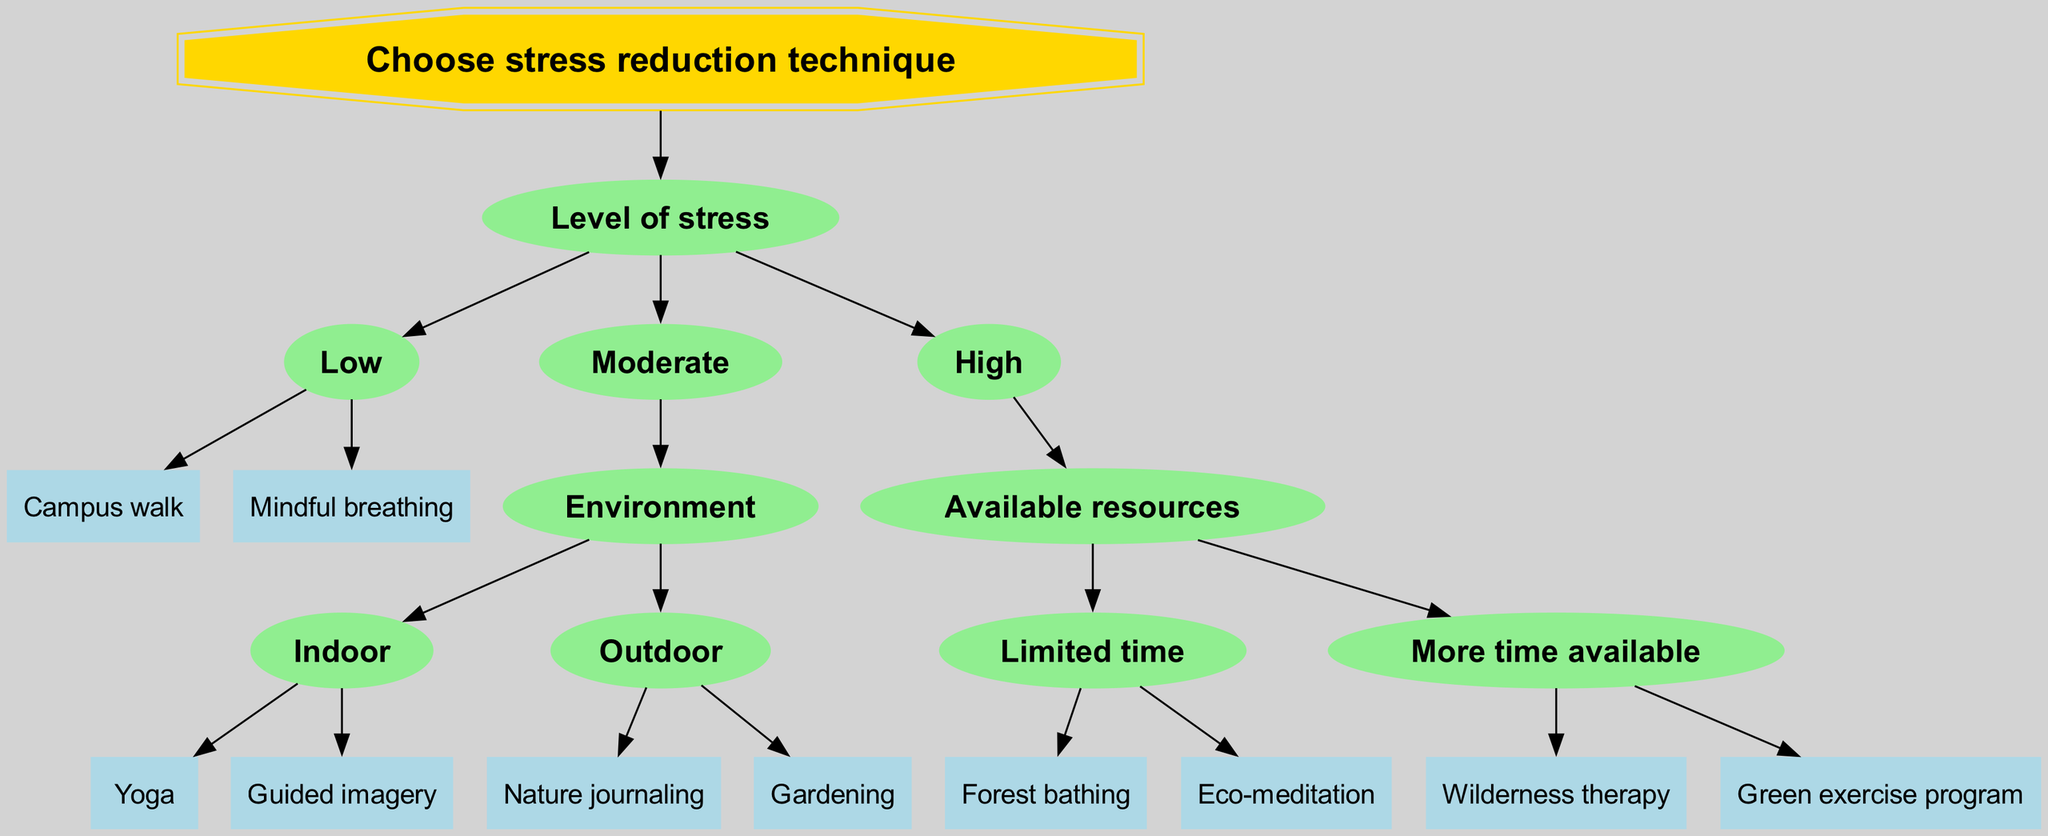What is the root node of the decision tree? The root node of the decision tree is the starting point from which all other nodes branch out. In this case, it is labeled "Choose stress reduction technique."
Answer: Choose stress reduction technique How many techniques are available for low stress levels? There are two techniques indicated under the "Low" stress level node, which are "Campus walk" and "Mindful breathing."
Answer: 2 Which technique is recommended for high stress with limited time? In the "High" stress level branch under "Limited time," there are two techniques specified, and one of them is "Forest bathing."
Answer: Forest bathing What are the options available for moderate stress in an outdoor environment? For "Moderate" stress, under the "Outdoor" node, the techniques provided are "Nature journaling" and "Gardening."
Answer: Nature journaling, Gardening What is the structure immediately below the "High" stress level? Below the "High" stress level, there are two branches based on "Available resources," which are "Limited time" and "More time available."
Answer: Available resources If a person is experiencing moderate stress indoors, which technique can they choose? In the "Moderate" stress level and "Indoor" environment, two techniques are listed: "Yoga" and "Guided imagery."
Answer: Yoga, Guided imagery What is the final leaf node for patients with high stress and more time available? For patients with "High" stress and "More time available," the techniques provided are "Wilderness therapy" and "Green exercise program." The answer here would be either of them as they are both leaf nodes.
Answer: Wilderness therapy, Green exercise program What node connects the "Indoor" and "Outdoor" options in the tree? The node that connects "Indoor" and "Outdoor" options is the "Environment" node, which categorizes the techniques based on where they are performed.
Answer: Environment 